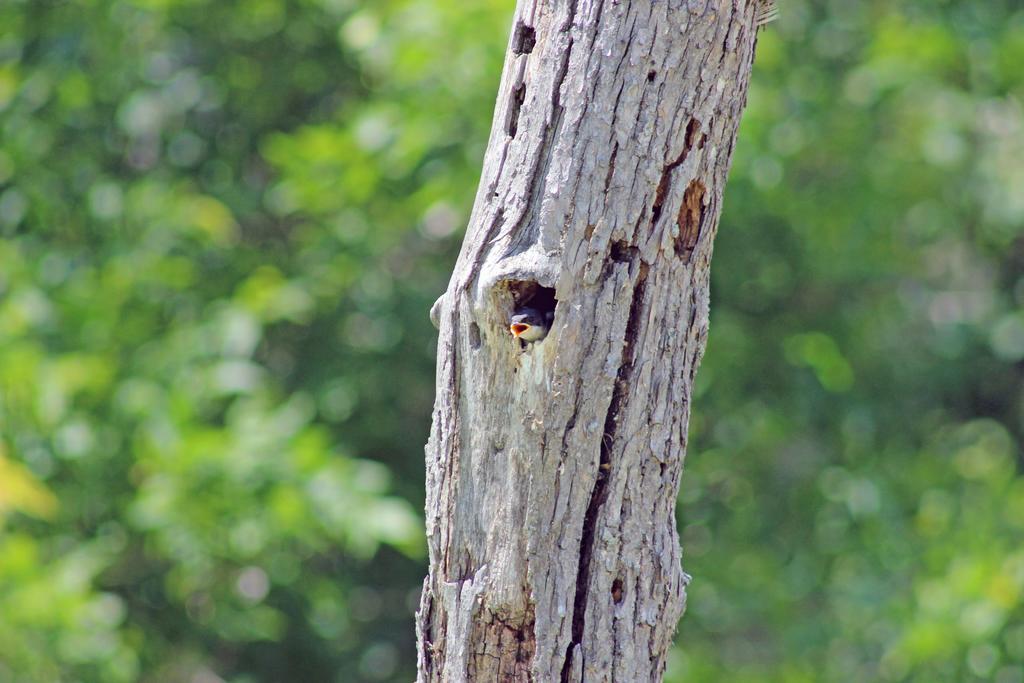Describe this image in one or two sentences. In this image there is a bird in the wooden trunk. Background there are few plants. 